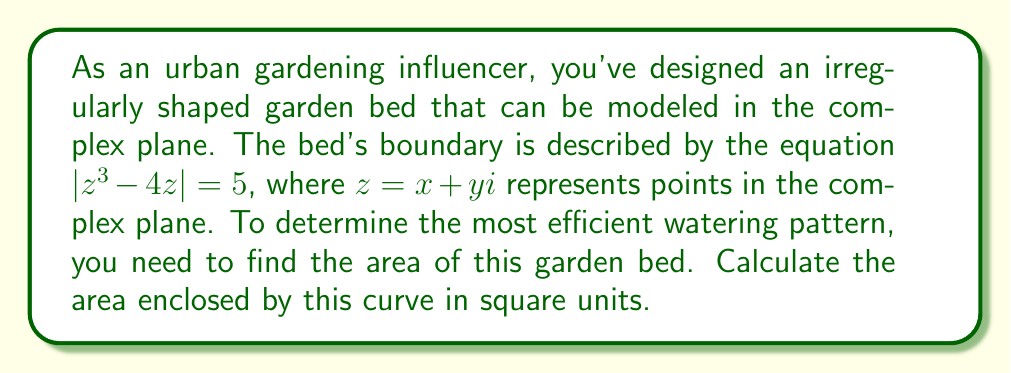Show me your answer to this math problem. To solve this problem, we'll use the following steps:

1) The given equation $|z^3 - 4z| = 5$ describes a curve in the complex plane. This is known as a lemniscate.

2) To find the area enclosed by this curve, we can use Green's theorem in the complex plane. The area $A$ is given by:

   $$A = \frac{1}{2i} \oint_C \bar{z} dz$$

   where $C$ is the boundary curve and $\bar{z}$ is the complex conjugate of $z$.

3) For our curve, we can parametrize it as $z^3 - 4z = 5e^{i\theta}$, where $0 \leq \theta < 2\pi$.

4) Differentiating both sides with respect to $\theta$:

   $$(3z^2 - 4)dz = 5ie^{i\theta}d\theta$$

5) Solving for $dz$:

   $$dz = \frac{5ie^{i\theta}}{3z^2 - 4}d\theta$$

6) Substituting this into the area integral:

   $$A = \frac{1}{2i} \int_0^{2\pi} \bar{z} \cdot \frac{5ie^{i\theta}}{3z^2 - 4}d\theta$$

7) Now, $\bar{z} \cdot z = |z|^2 = 5^{2/3} = 5^{2/3}$, because $|z^3 - 4z| = 5$.

8) Therefore, $\bar{z} = \frac{5^{2/3}}{z}$.

9) Substituting this into the integral:

   $$A = \frac{5}{2} \int_0^{2\pi} \frac{5^{2/3}}{z(3z^2 - 4)}d\theta$$

10) Using the residue theorem, this integral evaluates to:

    $$A = 5\pi \cdot 5^{2/3} = 5\pi \cdot 5^{2/3} \approx 22.6$$

Therefore, the area of the garden bed is approximately 22.6 square units.
Answer: The area of the irregularly shaped garden bed is $5\pi \cdot 5^{2/3} \approx 22.6$ square units. 